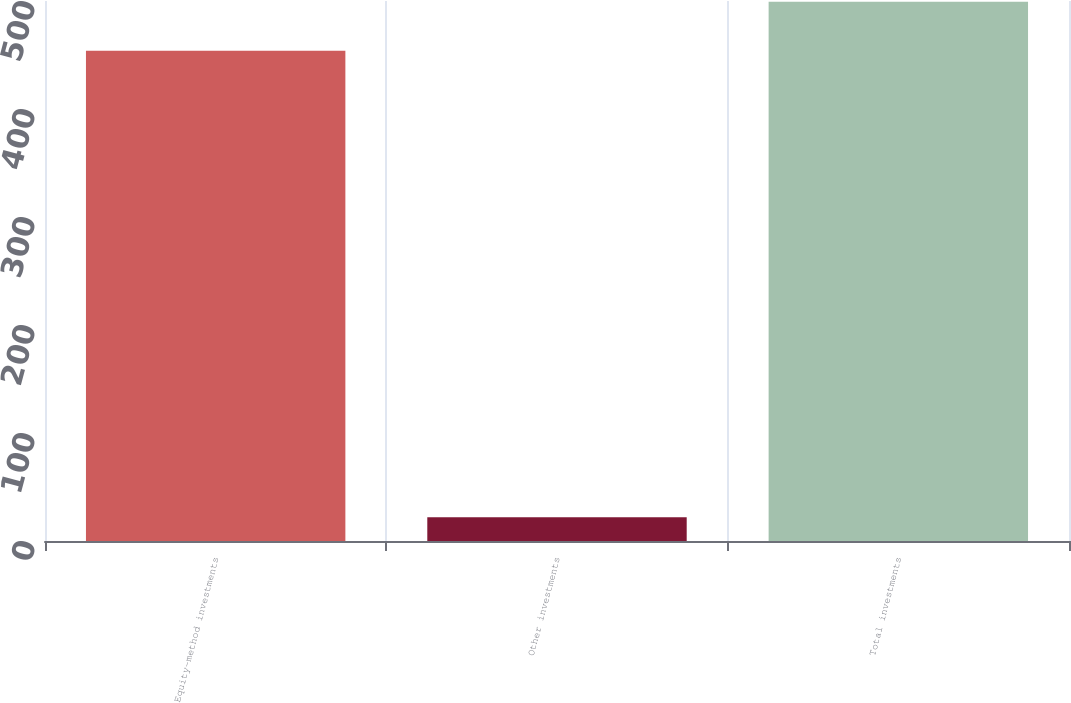Convert chart. <chart><loc_0><loc_0><loc_500><loc_500><bar_chart><fcel>Equity-method investments<fcel>Other investments<fcel>Total investments<nl><fcel>454<fcel>22<fcel>499.4<nl></chart> 